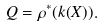Convert formula to latex. <formula><loc_0><loc_0><loc_500><loc_500>Q = \rho ^ { * } ( k ( X ) ) .</formula> 